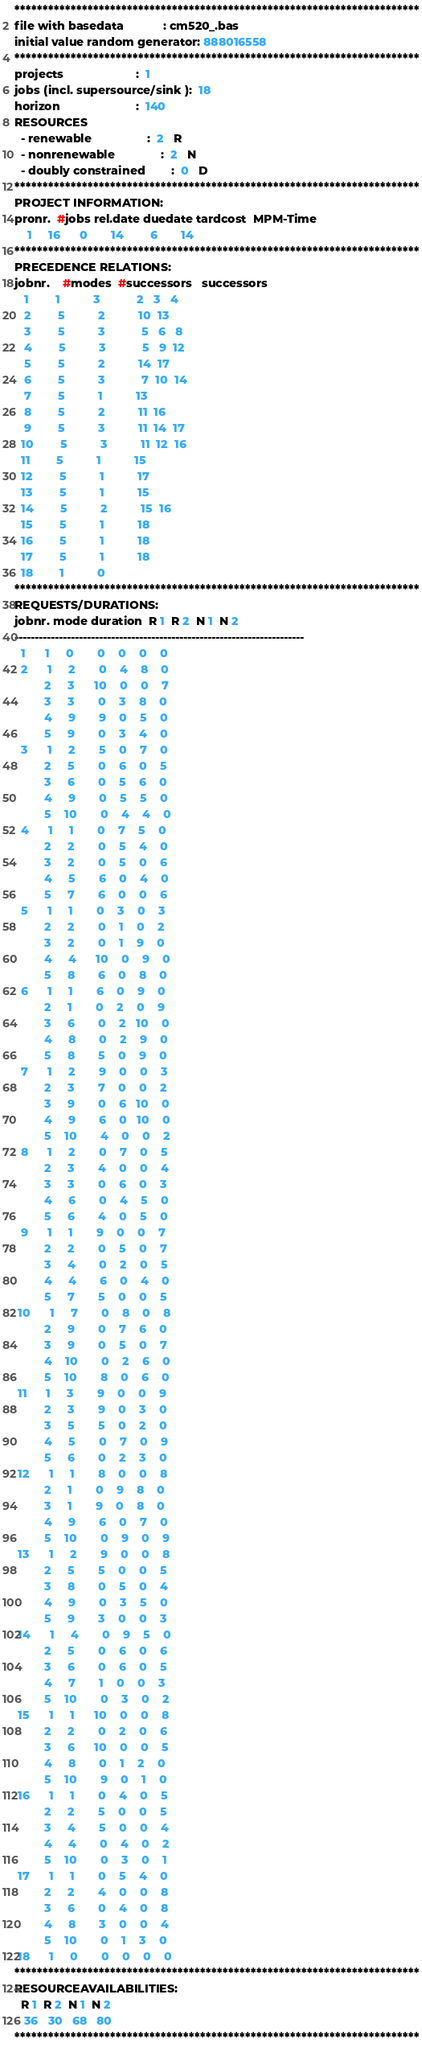<code> <loc_0><loc_0><loc_500><loc_500><_ObjectiveC_>************************************************************************
file with basedata            : cm520_.bas
initial value random generator: 888016558
************************************************************************
projects                      :  1
jobs (incl. supersource/sink ):  18
horizon                       :  140
RESOURCES
  - renewable                 :  2   R
  - nonrenewable              :  2   N
  - doubly constrained        :  0   D
************************************************************************
PROJECT INFORMATION:
pronr.  #jobs rel.date duedate tardcost  MPM-Time
    1     16      0       14        6       14
************************************************************************
PRECEDENCE RELATIONS:
jobnr.    #modes  #successors   successors
   1        1          3           2   3   4
   2        5          2          10  13
   3        5          3           5   6   8
   4        5          3           5   9  12
   5        5          2          14  17
   6        5          3           7  10  14
   7        5          1          13
   8        5          2          11  16
   9        5          3          11  14  17
  10        5          3          11  12  16
  11        5          1          15
  12        5          1          17
  13        5          1          15
  14        5          2          15  16
  15        5          1          18
  16        5          1          18
  17        5          1          18
  18        1          0        
************************************************************************
REQUESTS/DURATIONS:
jobnr. mode duration  R 1  R 2  N 1  N 2
------------------------------------------------------------------------
  1      1     0       0    0    0    0
  2      1     2       0    4    8    0
         2     3      10    0    0    7
         3     3       0    3    8    0
         4     9       9    0    5    0
         5     9       0    3    4    0
  3      1     2       5    0    7    0
         2     5       0    6    0    5
         3     6       0    5    6    0
         4     9       0    5    5    0
         5    10       0    4    4    0
  4      1     1       0    7    5    0
         2     2       0    5    4    0
         3     2       0    5    0    6
         4     5       6    0    4    0
         5     7       6    0    0    6
  5      1     1       0    3    0    3
         2     2       0    1    0    2
         3     2       0    1    9    0
         4     4      10    0    9    0
         5     8       6    0    8    0
  6      1     1       6    0    9    0
         2     1       0    2    0    9
         3     6       0    2   10    0
         4     8       0    2    9    0
         5     8       5    0    9    0
  7      1     2       9    0    0    3
         2     3       7    0    0    2
         3     9       0    6   10    0
         4     9       6    0   10    0
         5    10       4    0    0    2
  8      1     2       0    7    0    5
         2     3       4    0    0    4
         3     3       0    6    0    3
         4     6       0    4    5    0
         5     6       4    0    5    0
  9      1     1       9    0    0    7
         2     2       0    5    0    7
         3     4       0    2    0    5
         4     4       6    0    4    0
         5     7       5    0    0    5
 10      1     7       0    8    0    8
         2     9       0    7    6    0
         3     9       0    5    0    7
         4    10       0    2    6    0
         5    10       8    0    6    0
 11      1     3       9    0    0    9
         2     3       9    0    3    0
         3     5       5    0    2    0
         4     5       0    7    0    9
         5     6       0    2    3    0
 12      1     1       8    0    0    8
         2     1       0    9    8    0
         3     1       9    0    8    0
         4     9       6    0    7    0
         5    10       0    9    0    9
 13      1     2       9    0    0    8
         2     5       5    0    0    5
         3     8       0    5    0    4
         4     9       0    3    5    0
         5     9       3    0    0    3
 14      1     4       0    9    5    0
         2     5       0    6    0    6
         3     6       0    6    0    5
         4     7       1    0    0    3
         5    10       0    3    0    2
 15      1     1      10    0    0    8
         2     2       0    2    0    6
         3     6      10    0    0    5
         4     8       0    1    2    0
         5    10       9    0    1    0
 16      1     1       0    4    0    5
         2     2       5    0    0    5
         3     4       5    0    0    4
         4     4       0    4    0    2
         5    10       0    3    0    1
 17      1     1       0    5    4    0
         2     2       4    0    0    8
         3     6       0    4    0    8
         4     8       3    0    0    4
         5    10       0    1    3    0
 18      1     0       0    0    0    0
************************************************************************
RESOURCEAVAILABILITIES:
  R 1  R 2  N 1  N 2
   36   30   68   80
************************************************************************
</code> 